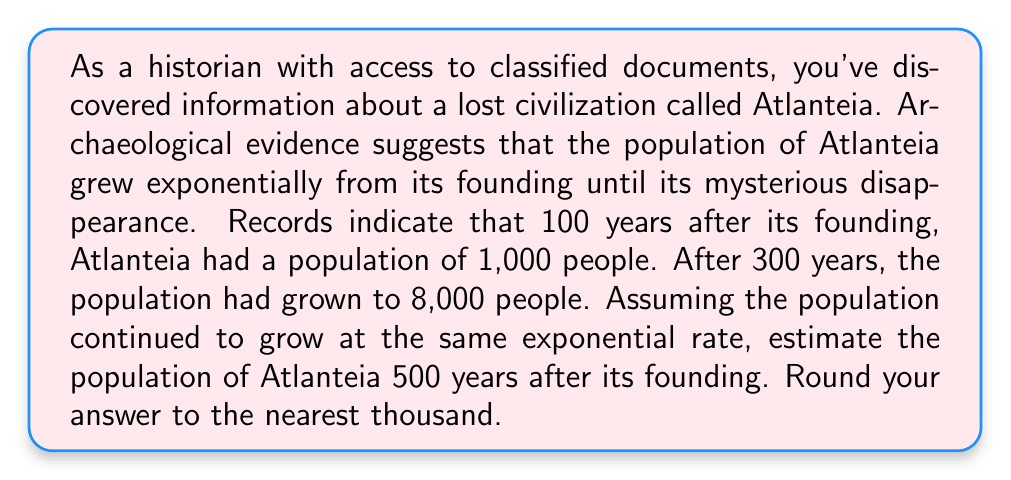Show me your answer to this math problem. To solve this problem, we'll use the exponential growth model:

$$P(t) = P_0 \cdot e^{rt}$$

Where:
$P(t)$ is the population at time $t$
$P_0$ is the initial population
$r$ is the growth rate
$t$ is the time

We have two data points:
1. At $t = 100$, $P(100) = 1,000$
2. At $t = 300$, $P(300) = 8,000$

Let's use these to find $r$:

$$8,000 = 1,000 \cdot e^{r(300-100)}$$
$$8 = e^{200r}$$

Taking the natural log of both sides:

$$\ln(8) = 200r$$
$$r = \frac{\ln(8)}{200} \approx 0.0104$$

Now that we have $r$, we can use the first data point to find $P_0$:

$$1,000 = P_0 \cdot e^{0.0104 \cdot 100}$$
$$P_0 = \frac{1,000}{e^{1.04}} \approx 353.55$$

With $P_0$ and $r$, we can now estimate the population at $t = 500$:

$$P(500) = 353.55 \cdot e^{0.0104 \cdot 500}$$
$$P(500) \approx 353.55 \cdot e^{5.2} \approx 64,145.76$$

Rounding to the nearest thousand, we get 64,000.
Answer: 64,000 people 